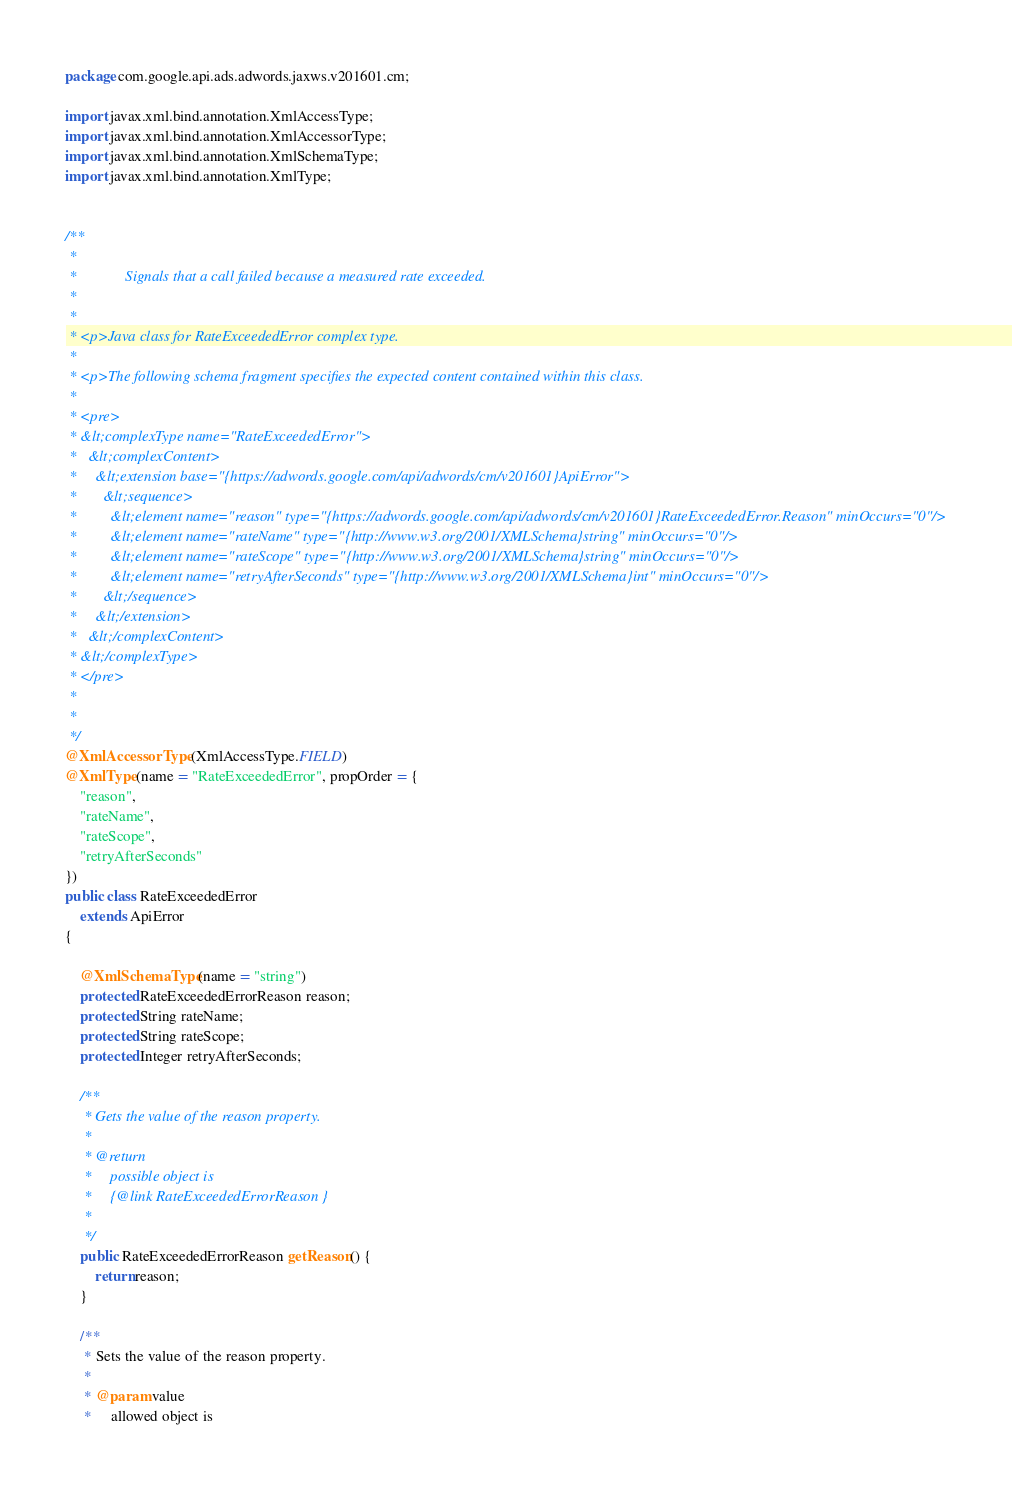<code> <loc_0><loc_0><loc_500><loc_500><_Java_>
package com.google.api.ads.adwords.jaxws.v201601.cm;

import javax.xml.bind.annotation.XmlAccessType;
import javax.xml.bind.annotation.XmlAccessorType;
import javax.xml.bind.annotation.XmlSchemaType;
import javax.xml.bind.annotation.XmlType;


/**
 * 
 *             Signals that a call failed because a measured rate exceeded.
 *           
 * 
 * <p>Java class for RateExceededError complex type.
 * 
 * <p>The following schema fragment specifies the expected content contained within this class.
 * 
 * <pre>
 * &lt;complexType name="RateExceededError">
 *   &lt;complexContent>
 *     &lt;extension base="{https://adwords.google.com/api/adwords/cm/v201601}ApiError">
 *       &lt;sequence>
 *         &lt;element name="reason" type="{https://adwords.google.com/api/adwords/cm/v201601}RateExceededError.Reason" minOccurs="0"/>
 *         &lt;element name="rateName" type="{http://www.w3.org/2001/XMLSchema}string" minOccurs="0"/>
 *         &lt;element name="rateScope" type="{http://www.w3.org/2001/XMLSchema}string" minOccurs="0"/>
 *         &lt;element name="retryAfterSeconds" type="{http://www.w3.org/2001/XMLSchema}int" minOccurs="0"/>
 *       &lt;/sequence>
 *     &lt;/extension>
 *   &lt;/complexContent>
 * &lt;/complexType>
 * </pre>
 * 
 * 
 */
@XmlAccessorType(XmlAccessType.FIELD)
@XmlType(name = "RateExceededError", propOrder = {
    "reason",
    "rateName",
    "rateScope",
    "retryAfterSeconds"
})
public class RateExceededError
    extends ApiError
{

    @XmlSchemaType(name = "string")
    protected RateExceededErrorReason reason;
    protected String rateName;
    protected String rateScope;
    protected Integer retryAfterSeconds;

    /**
     * Gets the value of the reason property.
     * 
     * @return
     *     possible object is
     *     {@link RateExceededErrorReason }
     *     
     */
    public RateExceededErrorReason getReason() {
        return reason;
    }

    /**
     * Sets the value of the reason property.
     * 
     * @param value
     *     allowed object is</code> 